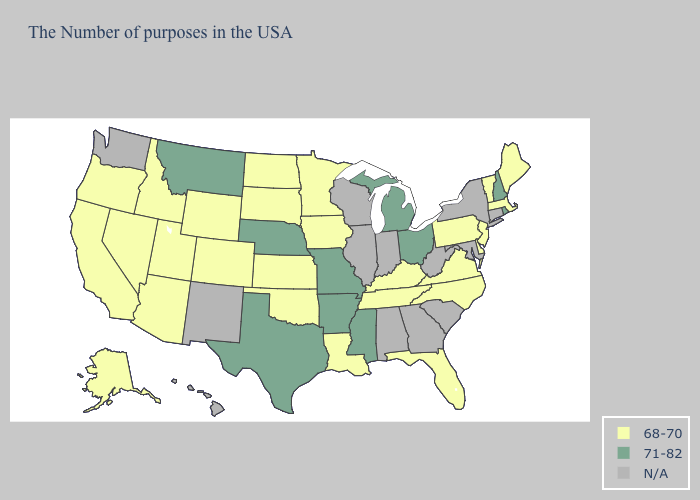Name the states that have a value in the range 71-82?
Answer briefly. Rhode Island, New Hampshire, Ohio, Michigan, Mississippi, Missouri, Arkansas, Nebraska, Texas, Montana. Among the states that border Colorado , which have the lowest value?
Short answer required. Kansas, Oklahoma, Wyoming, Utah, Arizona. Among the states that border Pennsylvania , does Ohio have the highest value?
Short answer required. Yes. Name the states that have a value in the range 68-70?
Concise answer only. Maine, Massachusetts, Vermont, New Jersey, Delaware, Pennsylvania, Virginia, North Carolina, Florida, Kentucky, Tennessee, Louisiana, Minnesota, Iowa, Kansas, Oklahoma, South Dakota, North Dakota, Wyoming, Colorado, Utah, Arizona, Idaho, Nevada, California, Oregon, Alaska. Among the states that border California , which have the lowest value?
Answer briefly. Arizona, Nevada, Oregon. What is the lowest value in states that border Indiana?
Concise answer only. 68-70. Does Arkansas have the lowest value in the South?
Quick response, please. No. What is the highest value in the Northeast ?
Short answer required. 71-82. Which states have the lowest value in the MidWest?
Give a very brief answer. Minnesota, Iowa, Kansas, South Dakota, North Dakota. Does Texas have the highest value in the South?
Answer briefly. Yes. Which states have the lowest value in the Northeast?
Answer briefly. Maine, Massachusetts, Vermont, New Jersey, Pennsylvania. Does the map have missing data?
Concise answer only. Yes. Does Florida have the highest value in the South?
Short answer required. No. 